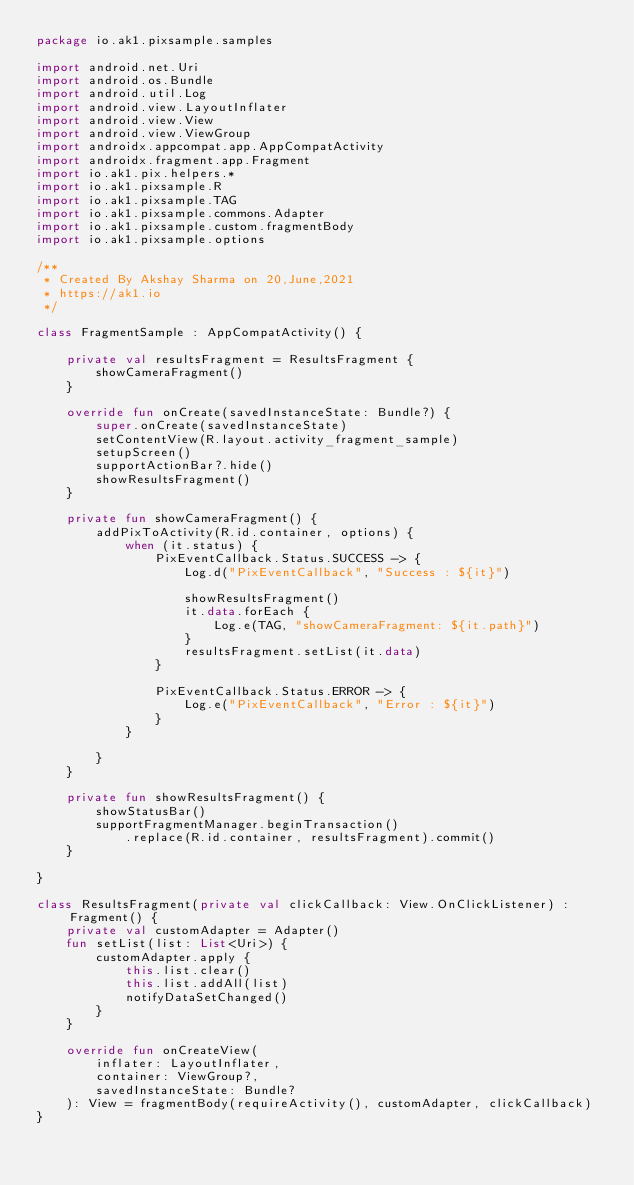<code> <loc_0><loc_0><loc_500><loc_500><_Kotlin_>package io.ak1.pixsample.samples

import android.net.Uri
import android.os.Bundle
import android.util.Log
import android.view.LayoutInflater
import android.view.View
import android.view.ViewGroup
import androidx.appcompat.app.AppCompatActivity
import androidx.fragment.app.Fragment
import io.ak1.pix.helpers.*
import io.ak1.pixsample.R
import io.ak1.pixsample.TAG
import io.ak1.pixsample.commons.Adapter
import io.ak1.pixsample.custom.fragmentBody
import io.ak1.pixsample.options

/**
 * Created By Akshay Sharma on 20,June,2021
 * https://ak1.io
 */

class FragmentSample : AppCompatActivity() {

    private val resultsFragment = ResultsFragment {
        showCameraFragment()
    }

    override fun onCreate(savedInstanceState: Bundle?) {
        super.onCreate(savedInstanceState)
        setContentView(R.layout.activity_fragment_sample)
        setupScreen()
        supportActionBar?.hide()
        showResultsFragment()
    }

    private fun showCameraFragment() {
        addPixToActivity(R.id.container, options) {
            when (it.status) {
                PixEventCallback.Status.SUCCESS -> {
                    Log.d("PixEventCallback", "Success : ${it}")

                    showResultsFragment()
                    it.data.forEach {
                        Log.e(TAG, "showCameraFragment: ${it.path}")
                    }
                    resultsFragment.setList(it.data)
                }

                PixEventCallback.Status.ERROR -> {
                    Log.e("PixEventCallback", "Error : ${it}")
                }
            }

        }
    }

    private fun showResultsFragment() {
        showStatusBar()
        supportFragmentManager.beginTransaction()
            .replace(R.id.container, resultsFragment).commit()
    }

}

class ResultsFragment(private val clickCallback: View.OnClickListener) : Fragment() {
    private val customAdapter = Adapter()
    fun setList(list: List<Uri>) {
        customAdapter.apply {
            this.list.clear()
            this.list.addAll(list)
            notifyDataSetChanged()
        }
    }

    override fun onCreateView(
        inflater: LayoutInflater,
        container: ViewGroup?,
        savedInstanceState: Bundle?
    ): View = fragmentBody(requireActivity(), customAdapter, clickCallback)
}
</code> 